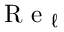Convert formula to latex. <formula><loc_0><loc_0><loc_500><loc_500>R e _ { \ell }</formula> 